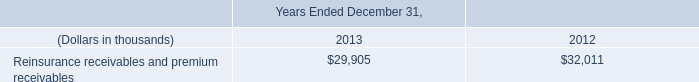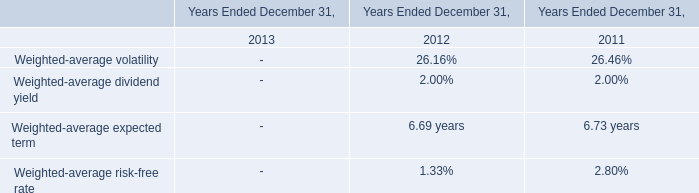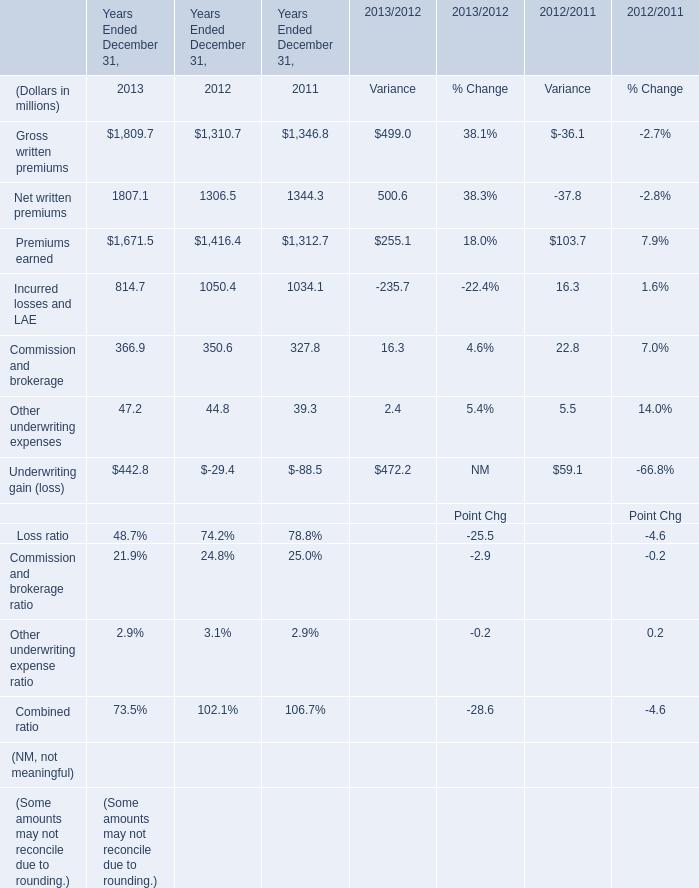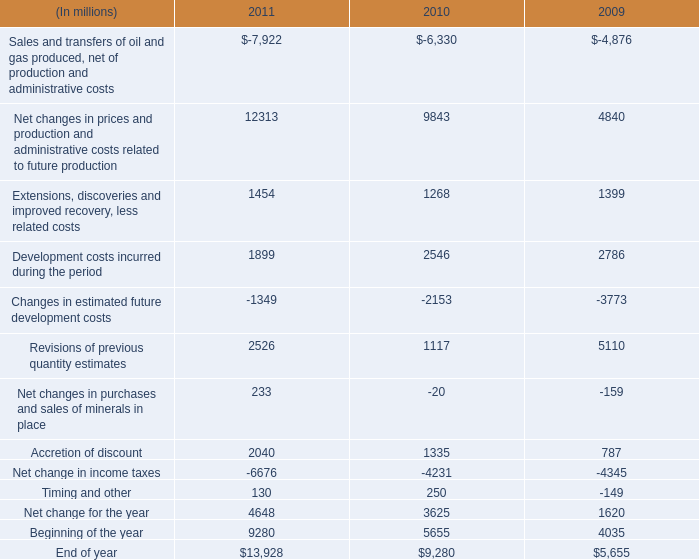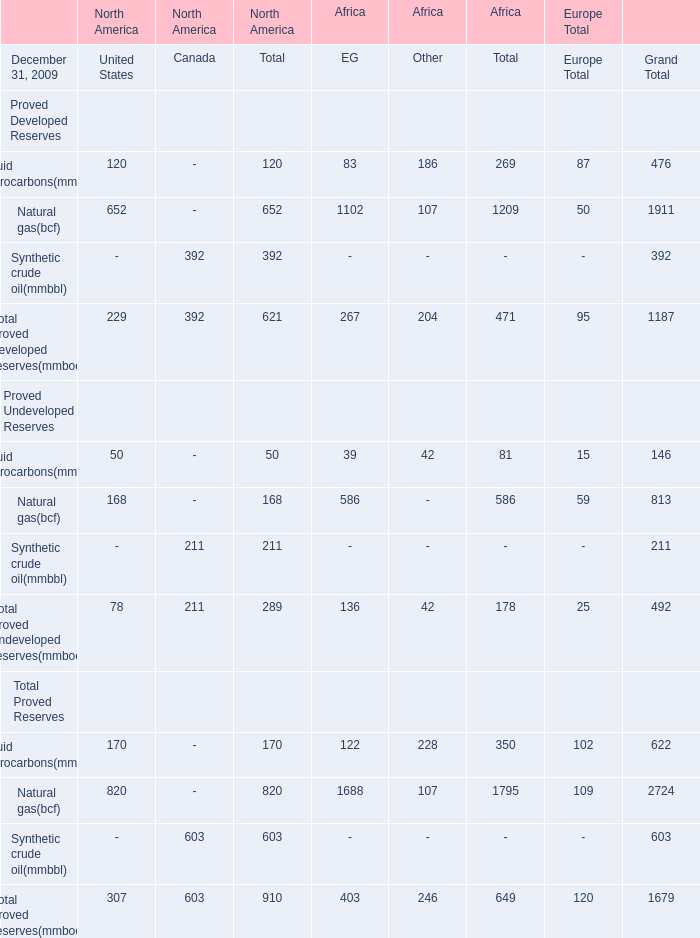What is the total amount of Incurred losses and LAE of Years Ended December 31, 2011, and Extensions, discoveries and improved recovery, less related costs of 2010 ? 
Computations: (1034.1 + 1268.0)
Answer: 2302.1. 